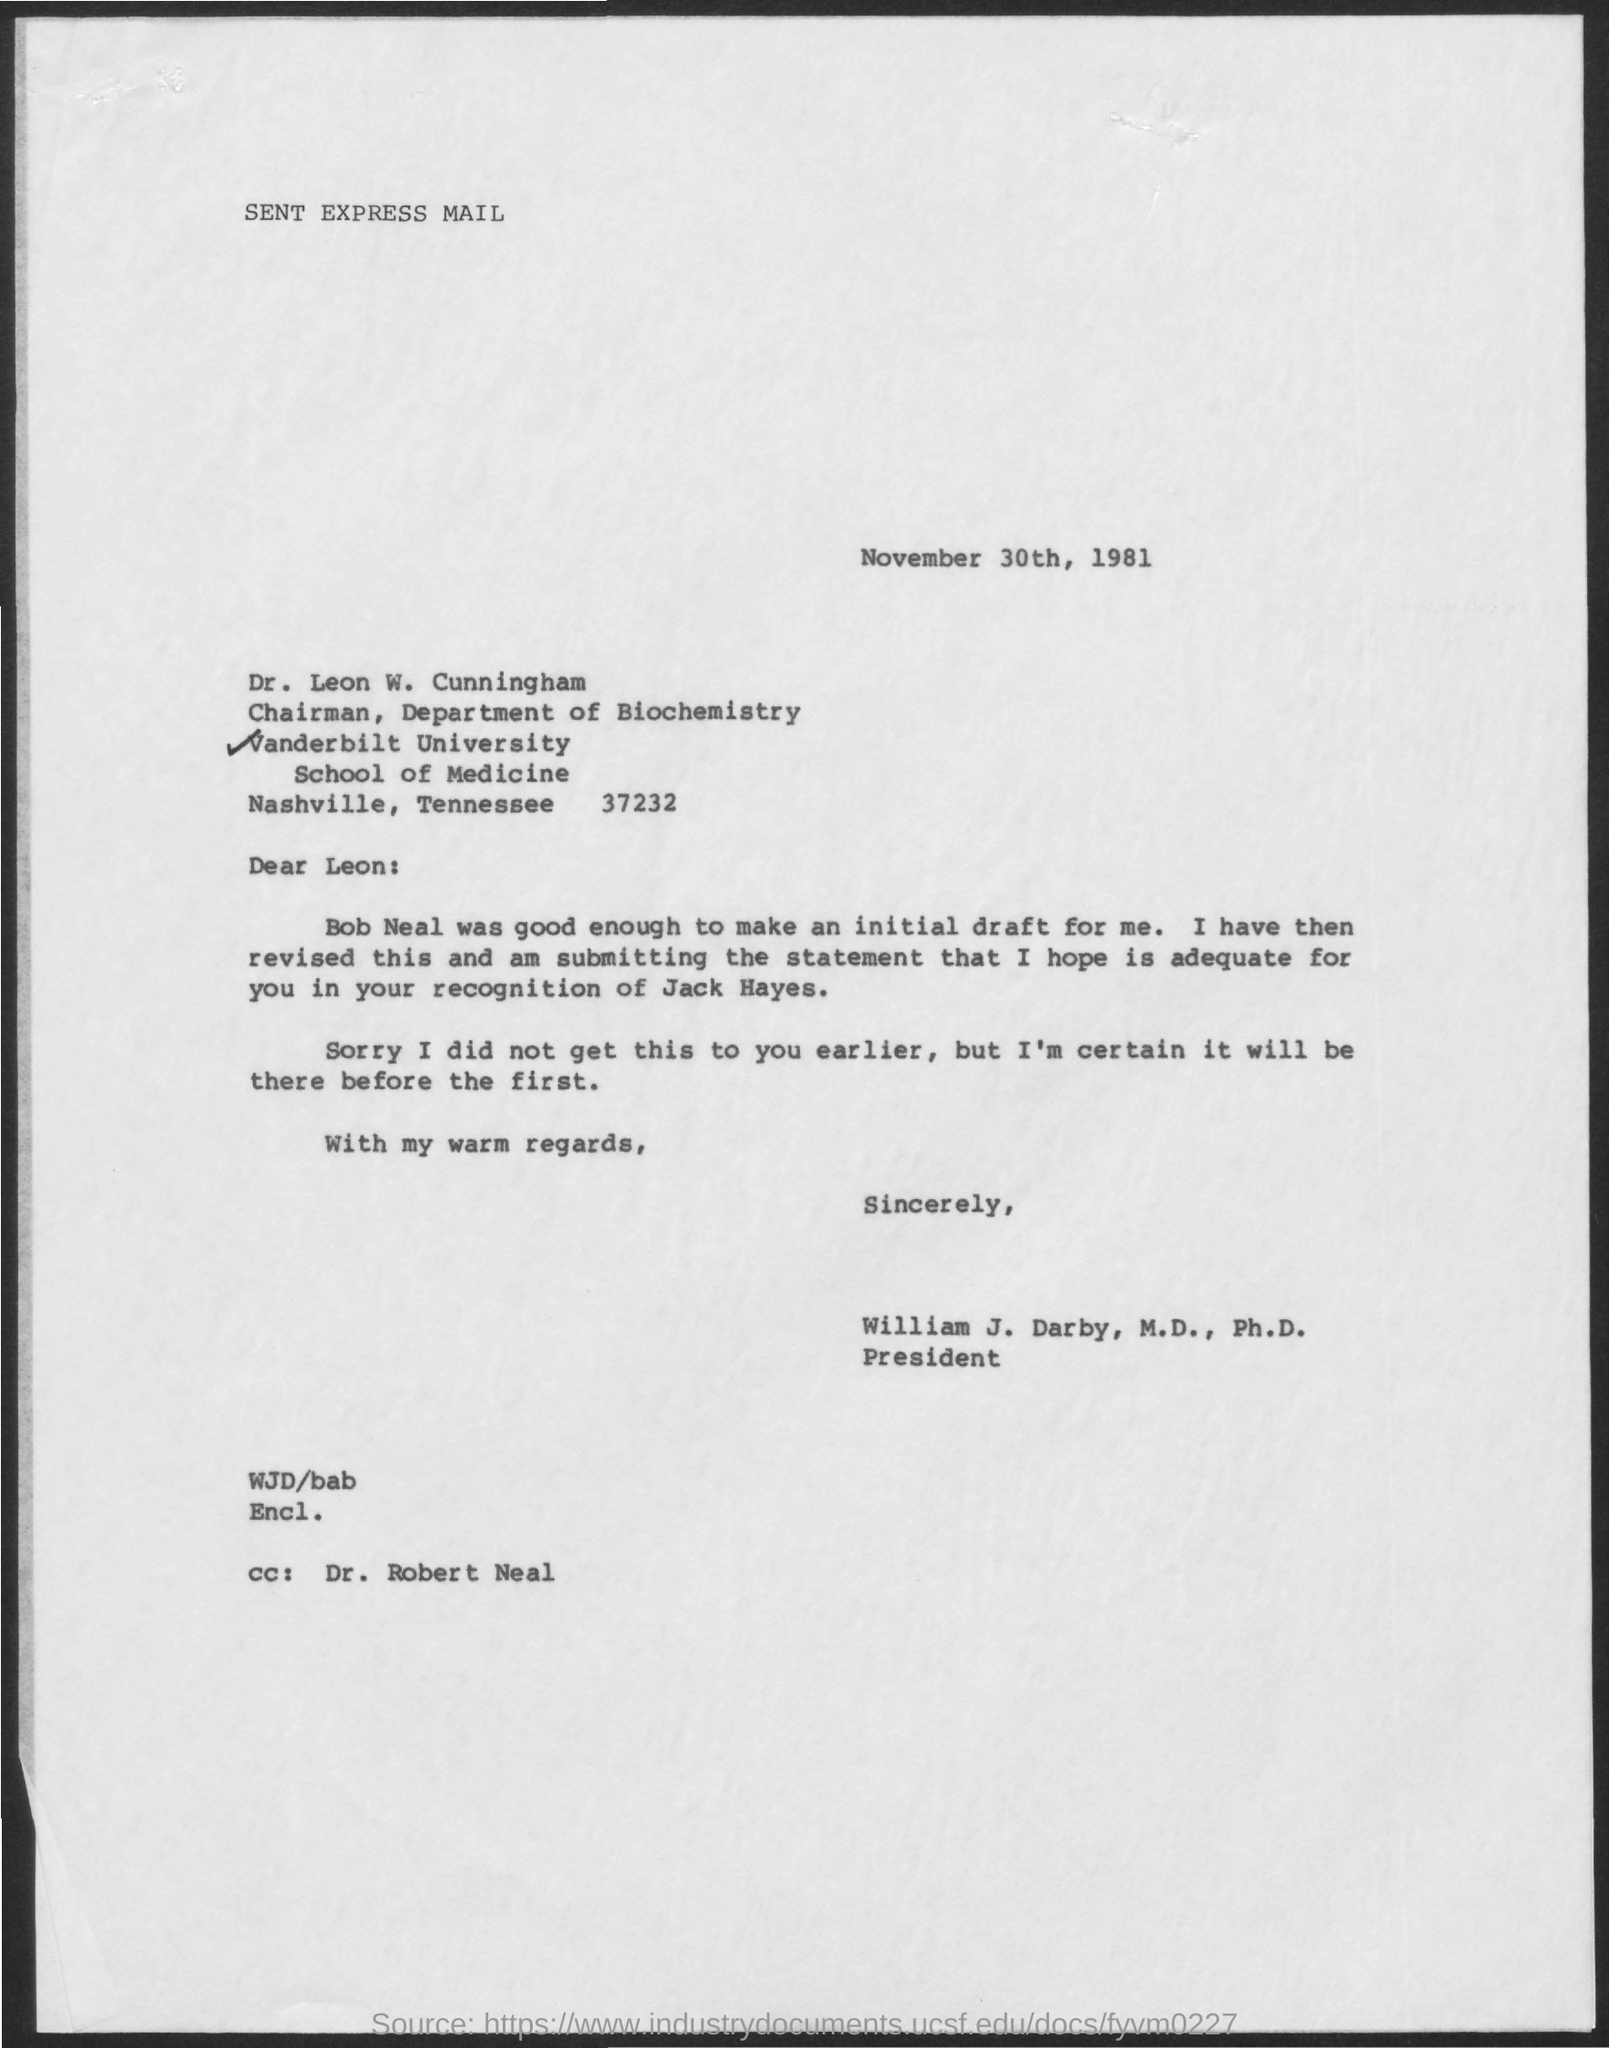What is the date on the document?
Your answer should be compact. November 30th, 1981. To Whom is this letter addressed to?
Your answer should be compact. Leon. Who was good enough to make the initial Draft?
Provide a short and direct response. Bob Neal. 